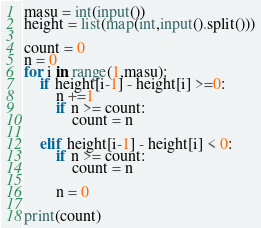Convert code to text. <code><loc_0><loc_0><loc_500><loc_500><_Python_>masu = int(input())
height = list(map(int,input().split()))

count = 0
n = 0
for i in range(1,masu):
    if height[i-1] - height[i] >=0:
        n +=1
        if n >= count:
            count = n
    
    elif height[i-1] - height[i] < 0:
        if n >= count:
            count = n
        
        n = 0

print(count)</code> 